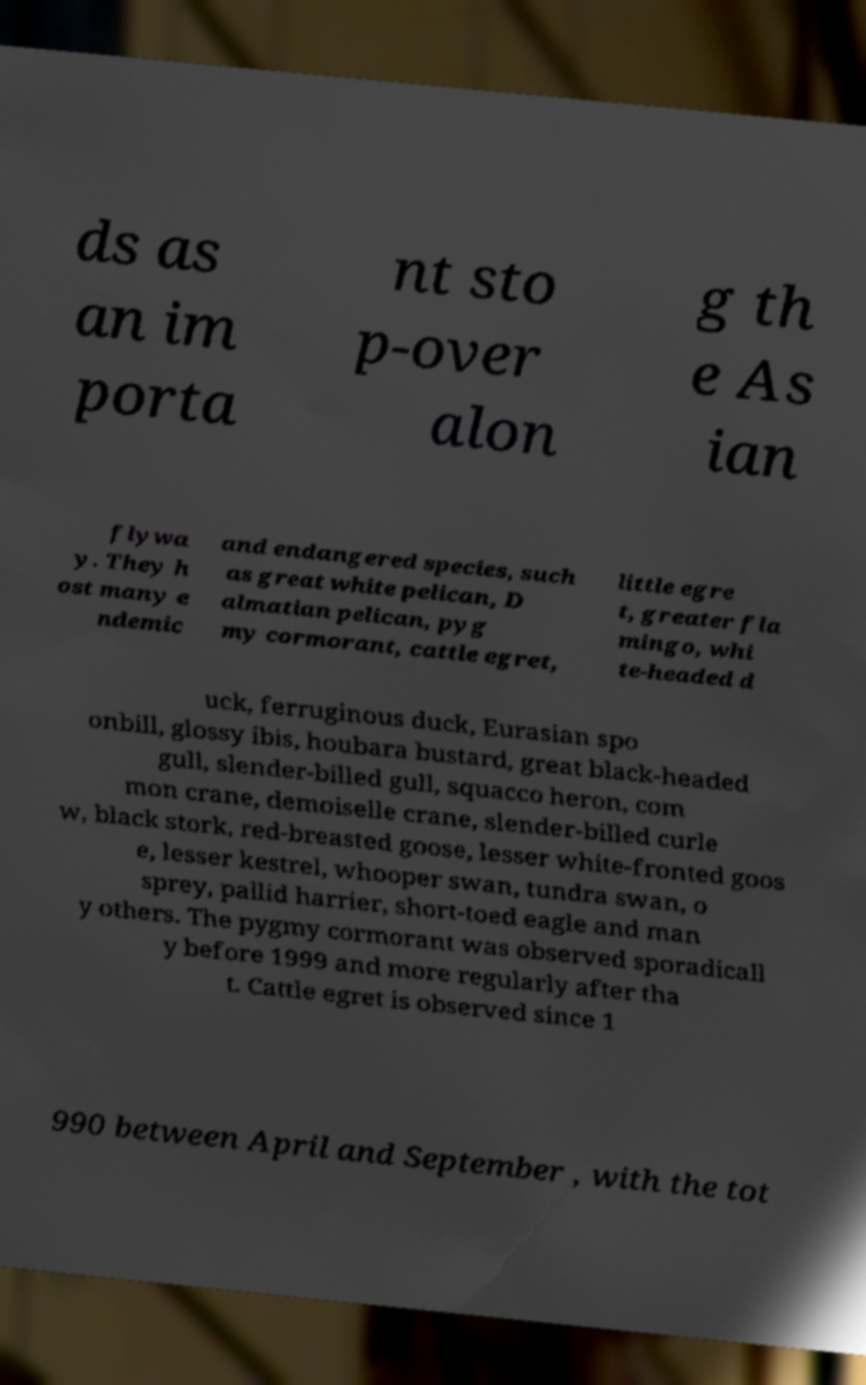What messages or text are displayed in this image? I need them in a readable, typed format. ds as an im porta nt sto p-over alon g th e As ian flywa y. They h ost many e ndemic and endangered species, such as great white pelican, D almatian pelican, pyg my cormorant, cattle egret, little egre t, greater fla mingo, whi te-headed d uck, ferruginous duck, Eurasian spo onbill, glossy ibis, houbara bustard, great black-headed gull, slender-billed gull, squacco heron, com mon crane, demoiselle crane, slender-billed curle w, black stork, red-breasted goose, lesser white-fronted goos e, lesser kestrel, whooper swan, tundra swan, o sprey, pallid harrier, short-toed eagle and man y others. The pygmy cormorant was observed sporadicall y before 1999 and more regularly after tha t. Cattle egret is observed since 1 990 between April and September , with the tot 